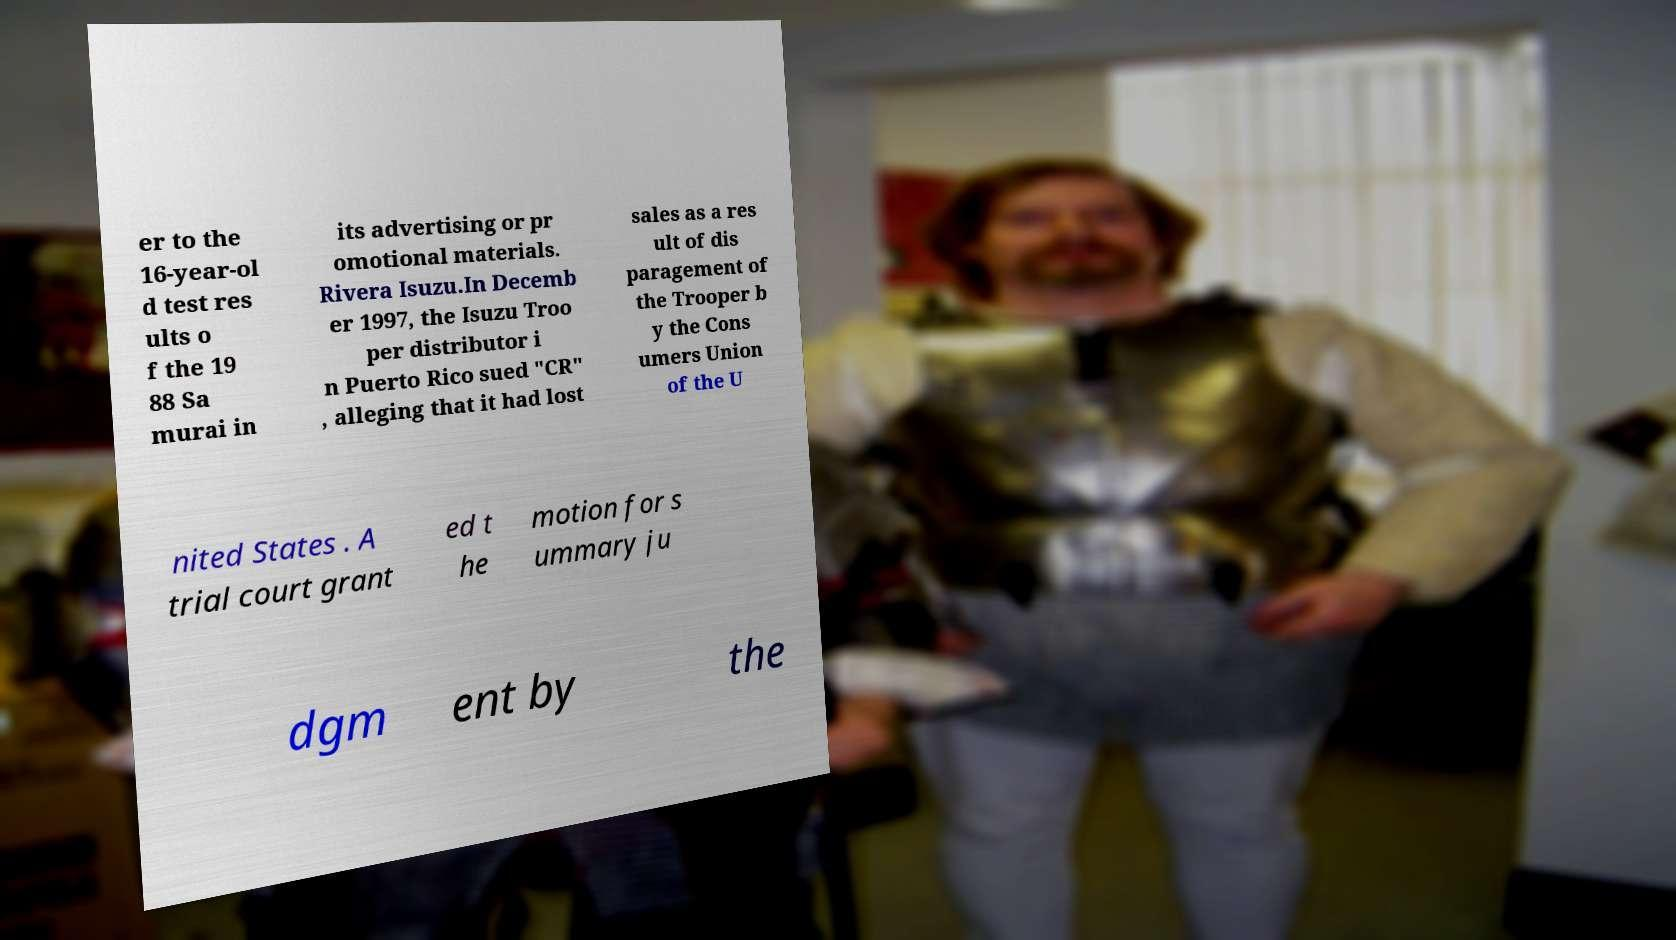Could you extract and type out the text from this image? er to the 16-year-ol d test res ults o f the 19 88 Sa murai in its advertising or pr omotional materials. Rivera Isuzu.In Decemb er 1997, the Isuzu Troo per distributor i n Puerto Rico sued "CR" , alleging that it had lost sales as a res ult of dis paragement of the Trooper b y the Cons umers Union of the U nited States . A trial court grant ed t he motion for s ummary ju dgm ent by the 